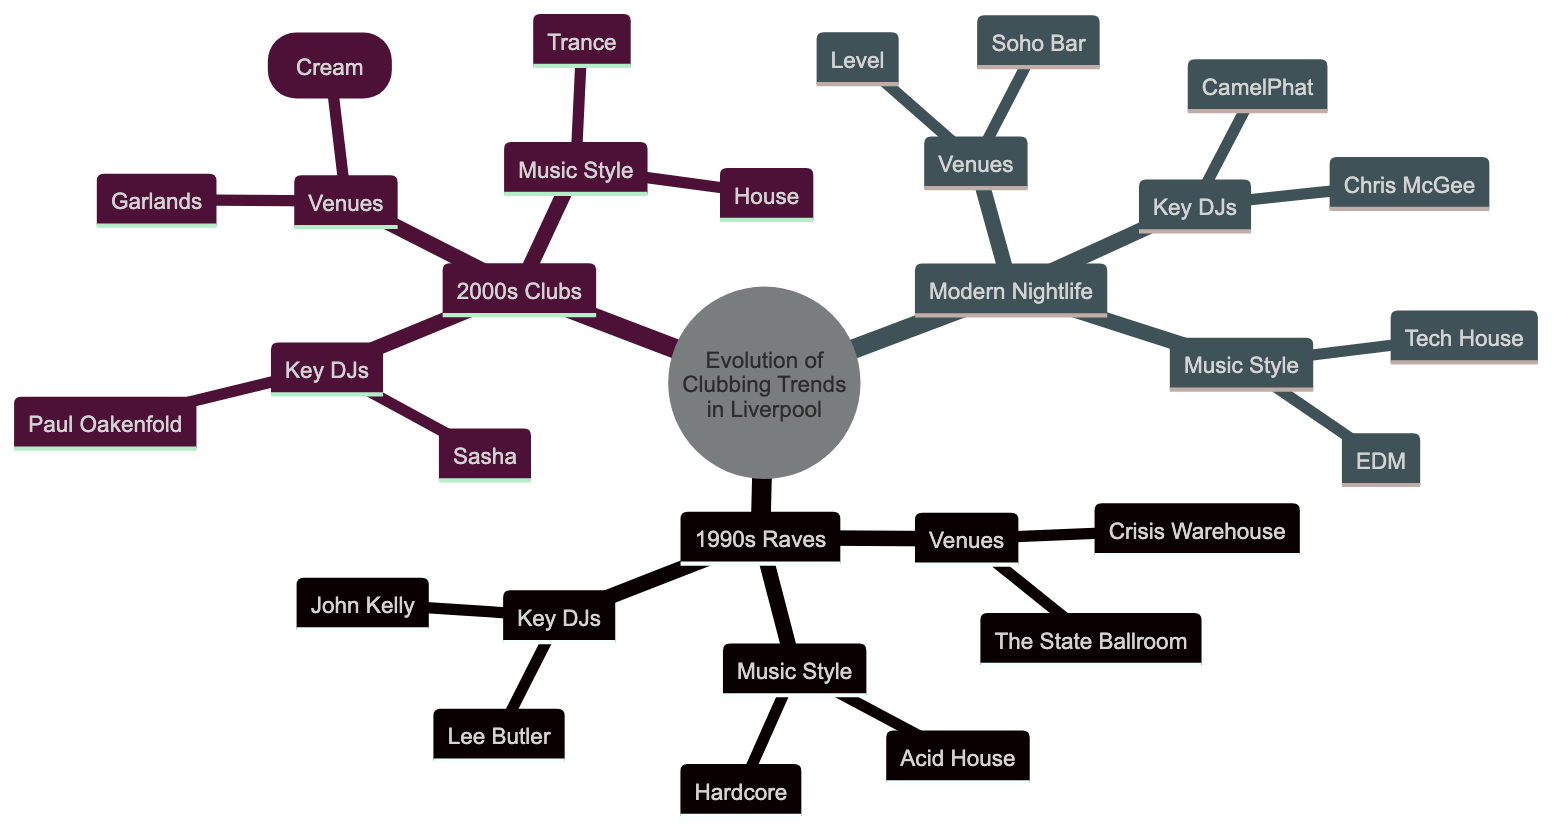What venues are listed under 1990s Raves? The diagram shows two venues listed under 1990s Raves: Crisis Warehouse and The State Ballroom. This is determined by looking at the child nodes under the "1990s Raves" parent node specifically for the "Venues" category.
Answer: Crisis Warehouse, The State Ballroom Which music style is associated with Modern Nightlife? The "Modern Nightlife" section of the diagram indicates two music styles: Tech House and EDM, categorized under the "Music Style" node. By reviewing the children under Modern Nightlife, the answer can be derived.
Answer: Tech House, EDM How many key DJs are mentioned for the 2000s Clubs? Under the "2000s Clubs" node, there are two key DJs listed: Sasha and Paul Oakenfold. This is found by counting the child nodes under the "Key DJs" section.
Answer: 2 Which type of clubbing trend was associated with Acid House? Acid House is identified under the "Music Style" section of the "1990s Raves," thus linking Acid House to this trend. By tracing the lineage from the top-level node down, the connection is made clear.
Answer: 1990s Raves What venue is most recently listed in the diagram? The most recent venue listed in the family tree is Soho Bar, found in the "Modern Nightlife" section, under its "Venues" node. This observation is made by checking the last part of the hierarchy.
Answer: Soho Bar 